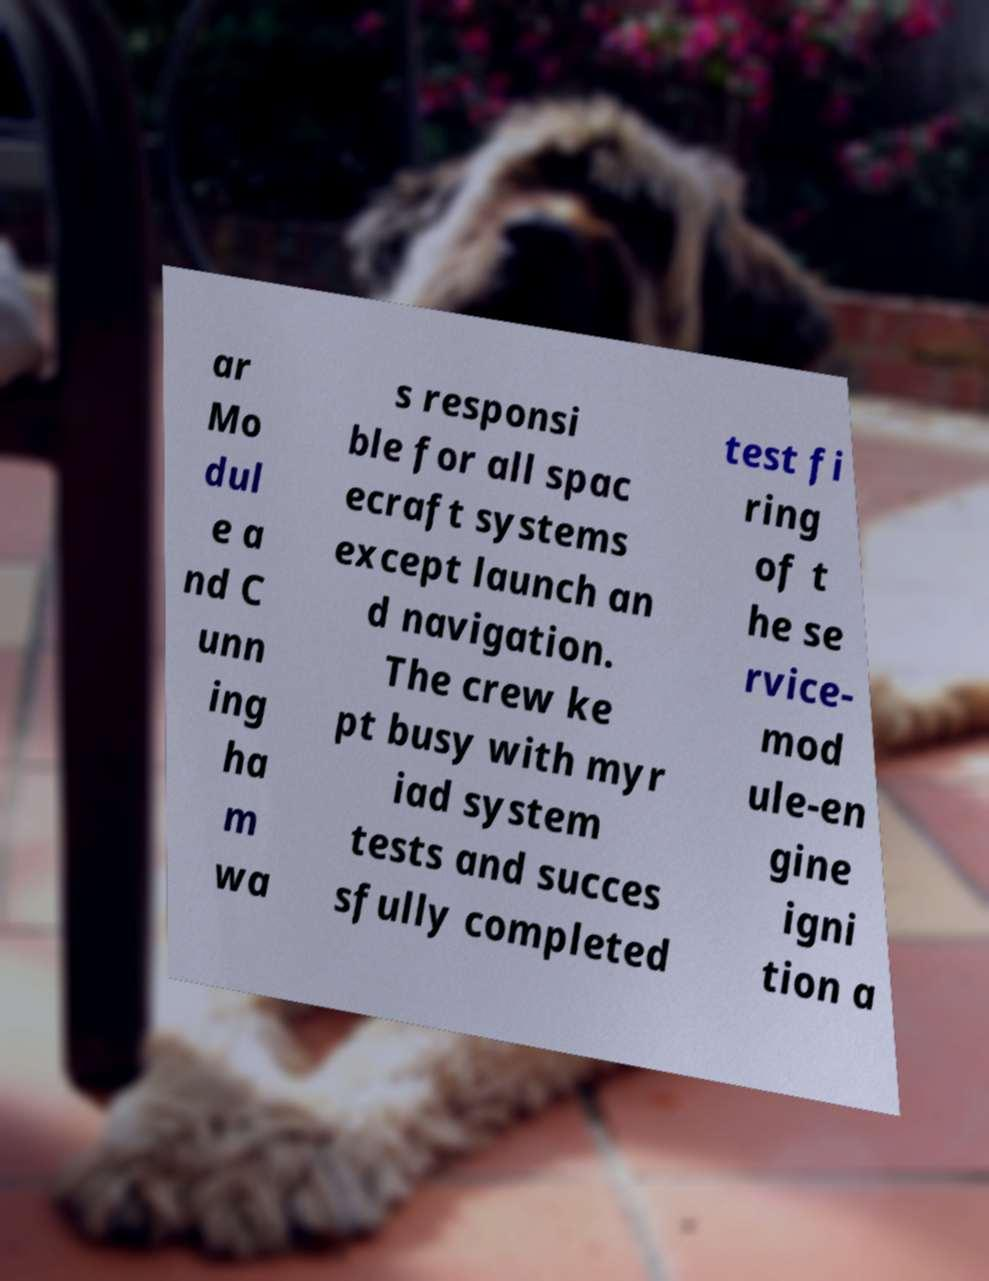Can you accurately transcribe the text from the provided image for me? ar Mo dul e a nd C unn ing ha m wa s responsi ble for all spac ecraft systems except launch an d navigation. The crew ke pt busy with myr iad system tests and succes sfully completed test fi ring of t he se rvice- mod ule-en gine igni tion a 